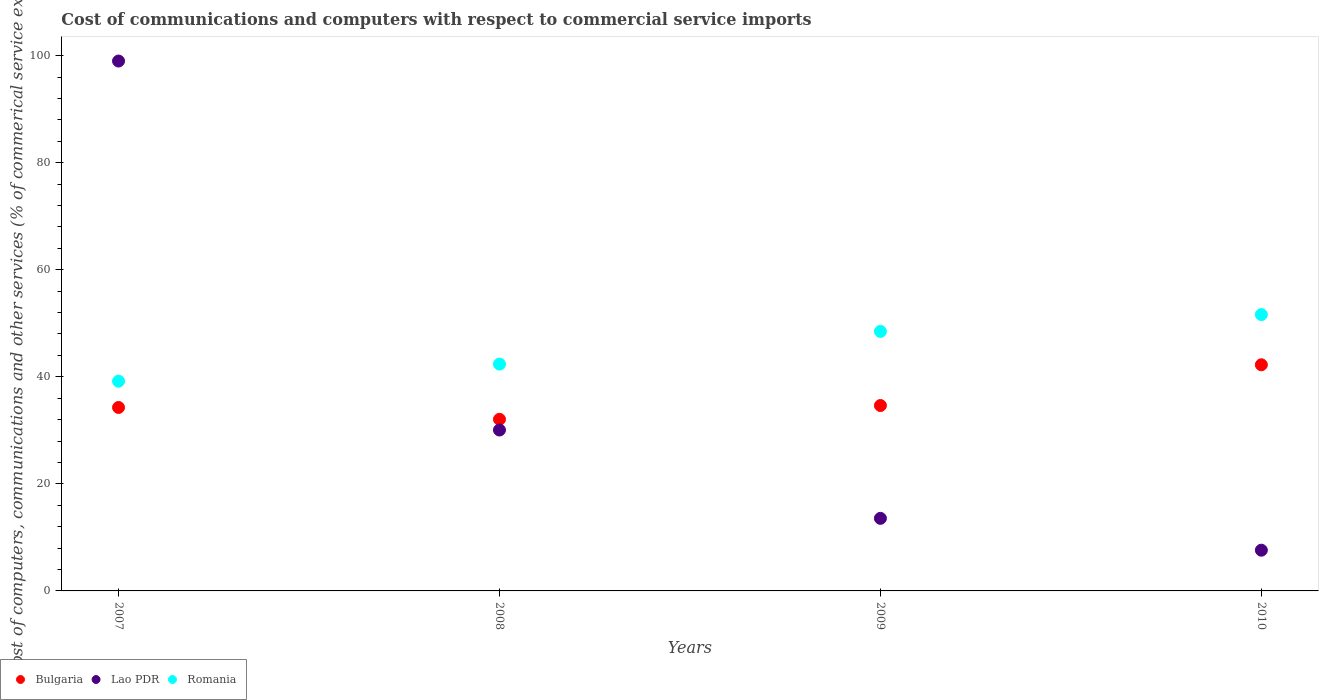How many different coloured dotlines are there?
Keep it short and to the point. 3. Is the number of dotlines equal to the number of legend labels?
Provide a short and direct response. Yes. What is the cost of communications and computers in Romania in 2009?
Ensure brevity in your answer.  48.48. Across all years, what is the maximum cost of communications and computers in Lao PDR?
Give a very brief answer. 98.99. Across all years, what is the minimum cost of communications and computers in Romania?
Provide a succinct answer. 39.18. In which year was the cost of communications and computers in Bulgaria maximum?
Your response must be concise. 2010. In which year was the cost of communications and computers in Romania minimum?
Offer a very short reply. 2007. What is the total cost of communications and computers in Bulgaria in the graph?
Offer a very short reply. 143.21. What is the difference between the cost of communications and computers in Lao PDR in 2008 and that in 2009?
Your response must be concise. 16.5. What is the difference between the cost of communications and computers in Romania in 2010 and the cost of communications and computers in Lao PDR in 2008?
Your answer should be very brief. 21.56. What is the average cost of communications and computers in Lao PDR per year?
Make the answer very short. 37.55. In the year 2010, what is the difference between the cost of communications and computers in Romania and cost of communications and computers in Lao PDR?
Provide a succinct answer. 44.01. In how many years, is the cost of communications and computers in Lao PDR greater than 56 %?
Offer a very short reply. 1. What is the ratio of the cost of communications and computers in Romania in 2007 to that in 2010?
Your response must be concise. 0.76. Is the difference between the cost of communications and computers in Romania in 2008 and 2010 greater than the difference between the cost of communications and computers in Lao PDR in 2008 and 2010?
Keep it short and to the point. No. What is the difference between the highest and the second highest cost of communications and computers in Lao PDR?
Your response must be concise. 68.93. What is the difference between the highest and the lowest cost of communications and computers in Lao PDR?
Offer a terse response. 91.38. In how many years, is the cost of communications and computers in Romania greater than the average cost of communications and computers in Romania taken over all years?
Your response must be concise. 2. Is the sum of the cost of communications and computers in Bulgaria in 2007 and 2008 greater than the maximum cost of communications and computers in Romania across all years?
Keep it short and to the point. Yes. How many dotlines are there?
Offer a very short reply. 3. What is the difference between two consecutive major ticks on the Y-axis?
Your response must be concise. 20. How many legend labels are there?
Provide a succinct answer. 3. How are the legend labels stacked?
Offer a very short reply. Horizontal. What is the title of the graph?
Ensure brevity in your answer.  Cost of communications and computers with respect to commercial service imports. Does "Liechtenstein" appear as one of the legend labels in the graph?
Your answer should be compact. No. What is the label or title of the Y-axis?
Provide a short and direct response. Cost of computers, communications and other services (% of commerical service exports). What is the Cost of computers, communications and other services (% of commerical service exports) in Bulgaria in 2007?
Your answer should be very brief. 34.27. What is the Cost of computers, communications and other services (% of commerical service exports) in Lao PDR in 2007?
Provide a short and direct response. 98.99. What is the Cost of computers, communications and other services (% of commerical service exports) in Romania in 2007?
Provide a short and direct response. 39.18. What is the Cost of computers, communications and other services (% of commerical service exports) of Bulgaria in 2008?
Keep it short and to the point. 32.06. What is the Cost of computers, communications and other services (% of commerical service exports) of Lao PDR in 2008?
Your response must be concise. 30.06. What is the Cost of computers, communications and other services (% of commerical service exports) of Romania in 2008?
Make the answer very short. 42.37. What is the Cost of computers, communications and other services (% of commerical service exports) of Bulgaria in 2009?
Offer a terse response. 34.63. What is the Cost of computers, communications and other services (% of commerical service exports) of Lao PDR in 2009?
Provide a short and direct response. 13.56. What is the Cost of computers, communications and other services (% of commerical service exports) of Romania in 2009?
Keep it short and to the point. 48.48. What is the Cost of computers, communications and other services (% of commerical service exports) of Bulgaria in 2010?
Offer a terse response. 42.25. What is the Cost of computers, communications and other services (% of commerical service exports) of Lao PDR in 2010?
Make the answer very short. 7.61. What is the Cost of computers, communications and other services (% of commerical service exports) of Romania in 2010?
Give a very brief answer. 51.62. Across all years, what is the maximum Cost of computers, communications and other services (% of commerical service exports) of Bulgaria?
Keep it short and to the point. 42.25. Across all years, what is the maximum Cost of computers, communications and other services (% of commerical service exports) of Lao PDR?
Your answer should be compact. 98.99. Across all years, what is the maximum Cost of computers, communications and other services (% of commerical service exports) in Romania?
Offer a terse response. 51.62. Across all years, what is the minimum Cost of computers, communications and other services (% of commerical service exports) of Bulgaria?
Give a very brief answer. 32.06. Across all years, what is the minimum Cost of computers, communications and other services (% of commerical service exports) of Lao PDR?
Your answer should be very brief. 7.61. Across all years, what is the minimum Cost of computers, communications and other services (% of commerical service exports) in Romania?
Offer a terse response. 39.18. What is the total Cost of computers, communications and other services (% of commerical service exports) of Bulgaria in the graph?
Your response must be concise. 143.21. What is the total Cost of computers, communications and other services (% of commerical service exports) of Lao PDR in the graph?
Your response must be concise. 150.21. What is the total Cost of computers, communications and other services (% of commerical service exports) in Romania in the graph?
Give a very brief answer. 181.66. What is the difference between the Cost of computers, communications and other services (% of commerical service exports) of Bulgaria in 2007 and that in 2008?
Make the answer very short. 2.21. What is the difference between the Cost of computers, communications and other services (% of commerical service exports) in Lao PDR in 2007 and that in 2008?
Keep it short and to the point. 68.93. What is the difference between the Cost of computers, communications and other services (% of commerical service exports) of Romania in 2007 and that in 2008?
Ensure brevity in your answer.  -3.19. What is the difference between the Cost of computers, communications and other services (% of commerical service exports) of Bulgaria in 2007 and that in 2009?
Make the answer very short. -0.36. What is the difference between the Cost of computers, communications and other services (% of commerical service exports) in Lao PDR in 2007 and that in 2009?
Provide a succinct answer. 85.43. What is the difference between the Cost of computers, communications and other services (% of commerical service exports) of Romania in 2007 and that in 2009?
Make the answer very short. -9.3. What is the difference between the Cost of computers, communications and other services (% of commerical service exports) in Bulgaria in 2007 and that in 2010?
Provide a succinct answer. -7.98. What is the difference between the Cost of computers, communications and other services (% of commerical service exports) of Lao PDR in 2007 and that in 2010?
Provide a short and direct response. 91.38. What is the difference between the Cost of computers, communications and other services (% of commerical service exports) in Romania in 2007 and that in 2010?
Offer a very short reply. -12.44. What is the difference between the Cost of computers, communications and other services (% of commerical service exports) in Bulgaria in 2008 and that in 2009?
Your answer should be compact. -2.58. What is the difference between the Cost of computers, communications and other services (% of commerical service exports) of Lao PDR in 2008 and that in 2009?
Offer a terse response. 16.5. What is the difference between the Cost of computers, communications and other services (% of commerical service exports) in Romania in 2008 and that in 2009?
Give a very brief answer. -6.11. What is the difference between the Cost of computers, communications and other services (% of commerical service exports) of Bulgaria in 2008 and that in 2010?
Give a very brief answer. -10.19. What is the difference between the Cost of computers, communications and other services (% of commerical service exports) of Lao PDR in 2008 and that in 2010?
Your response must be concise. 22.45. What is the difference between the Cost of computers, communications and other services (% of commerical service exports) of Romania in 2008 and that in 2010?
Provide a short and direct response. -9.25. What is the difference between the Cost of computers, communications and other services (% of commerical service exports) in Bulgaria in 2009 and that in 2010?
Give a very brief answer. -7.61. What is the difference between the Cost of computers, communications and other services (% of commerical service exports) in Lao PDR in 2009 and that in 2010?
Your response must be concise. 5.95. What is the difference between the Cost of computers, communications and other services (% of commerical service exports) of Romania in 2009 and that in 2010?
Keep it short and to the point. -3.14. What is the difference between the Cost of computers, communications and other services (% of commerical service exports) of Bulgaria in 2007 and the Cost of computers, communications and other services (% of commerical service exports) of Lao PDR in 2008?
Your answer should be compact. 4.21. What is the difference between the Cost of computers, communications and other services (% of commerical service exports) in Bulgaria in 2007 and the Cost of computers, communications and other services (% of commerical service exports) in Romania in 2008?
Offer a terse response. -8.1. What is the difference between the Cost of computers, communications and other services (% of commerical service exports) in Lao PDR in 2007 and the Cost of computers, communications and other services (% of commerical service exports) in Romania in 2008?
Your answer should be compact. 56.62. What is the difference between the Cost of computers, communications and other services (% of commerical service exports) in Bulgaria in 2007 and the Cost of computers, communications and other services (% of commerical service exports) in Lao PDR in 2009?
Offer a terse response. 20.71. What is the difference between the Cost of computers, communications and other services (% of commerical service exports) of Bulgaria in 2007 and the Cost of computers, communications and other services (% of commerical service exports) of Romania in 2009?
Provide a short and direct response. -14.21. What is the difference between the Cost of computers, communications and other services (% of commerical service exports) in Lao PDR in 2007 and the Cost of computers, communications and other services (% of commerical service exports) in Romania in 2009?
Give a very brief answer. 50.5. What is the difference between the Cost of computers, communications and other services (% of commerical service exports) of Bulgaria in 2007 and the Cost of computers, communications and other services (% of commerical service exports) of Lao PDR in 2010?
Offer a very short reply. 26.66. What is the difference between the Cost of computers, communications and other services (% of commerical service exports) in Bulgaria in 2007 and the Cost of computers, communications and other services (% of commerical service exports) in Romania in 2010?
Offer a very short reply. -17.35. What is the difference between the Cost of computers, communications and other services (% of commerical service exports) of Lao PDR in 2007 and the Cost of computers, communications and other services (% of commerical service exports) of Romania in 2010?
Provide a succinct answer. 47.36. What is the difference between the Cost of computers, communications and other services (% of commerical service exports) of Bulgaria in 2008 and the Cost of computers, communications and other services (% of commerical service exports) of Lao PDR in 2009?
Ensure brevity in your answer.  18.5. What is the difference between the Cost of computers, communications and other services (% of commerical service exports) in Bulgaria in 2008 and the Cost of computers, communications and other services (% of commerical service exports) in Romania in 2009?
Give a very brief answer. -16.43. What is the difference between the Cost of computers, communications and other services (% of commerical service exports) of Lao PDR in 2008 and the Cost of computers, communications and other services (% of commerical service exports) of Romania in 2009?
Your answer should be compact. -18.43. What is the difference between the Cost of computers, communications and other services (% of commerical service exports) in Bulgaria in 2008 and the Cost of computers, communications and other services (% of commerical service exports) in Lao PDR in 2010?
Provide a short and direct response. 24.45. What is the difference between the Cost of computers, communications and other services (% of commerical service exports) of Bulgaria in 2008 and the Cost of computers, communications and other services (% of commerical service exports) of Romania in 2010?
Your response must be concise. -19.57. What is the difference between the Cost of computers, communications and other services (% of commerical service exports) in Lao PDR in 2008 and the Cost of computers, communications and other services (% of commerical service exports) in Romania in 2010?
Provide a succinct answer. -21.56. What is the difference between the Cost of computers, communications and other services (% of commerical service exports) of Bulgaria in 2009 and the Cost of computers, communications and other services (% of commerical service exports) of Lao PDR in 2010?
Keep it short and to the point. 27.03. What is the difference between the Cost of computers, communications and other services (% of commerical service exports) in Bulgaria in 2009 and the Cost of computers, communications and other services (% of commerical service exports) in Romania in 2010?
Keep it short and to the point. -16.99. What is the difference between the Cost of computers, communications and other services (% of commerical service exports) in Lao PDR in 2009 and the Cost of computers, communications and other services (% of commerical service exports) in Romania in 2010?
Provide a succinct answer. -38.06. What is the average Cost of computers, communications and other services (% of commerical service exports) of Bulgaria per year?
Provide a succinct answer. 35.8. What is the average Cost of computers, communications and other services (% of commerical service exports) of Lao PDR per year?
Offer a very short reply. 37.55. What is the average Cost of computers, communications and other services (% of commerical service exports) of Romania per year?
Your answer should be very brief. 45.41. In the year 2007, what is the difference between the Cost of computers, communications and other services (% of commerical service exports) of Bulgaria and Cost of computers, communications and other services (% of commerical service exports) of Lao PDR?
Make the answer very short. -64.72. In the year 2007, what is the difference between the Cost of computers, communications and other services (% of commerical service exports) in Bulgaria and Cost of computers, communications and other services (% of commerical service exports) in Romania?
Offer a terse response. -4.91. In the year 2007, what is the difference between the Cost of computers, communications and other services (% of commerical service exports) of Lao PDR and Cost of computers, communications and other services (% of commerical service exports) of Romania?
Give a very brief answer. 59.81. In the year 2008, what is the difference between the Cost of computers, communications and other services (% of commerical service exports) of Bulgaria and Cost of computers, communications and other services (% of commerical service exports) of Lao PDR?
Make the answer very short. 2. In the year 2008, what is the difference between the Cost of computers, communications and other services (% of commerical service exports) in Bulgaria and Cost of computers, communications and other services (% of commerical service exports) in Romania?
Give a very brief answer. -10.31. In the year 2008, what is the difference between the Cost of computers, communications and other services (% of commerical service exports) of Lao PDR and Cost of computers, communications and other services (% of commerical service exports) of Romania?
Offer a terse response. -12.31. In the year 2009, what is the difference between the Cost of computers, communications and other services (% of commerical service exports) in Bulgaria and Cost of computers, communications and other services (% of commerical service exports) in Lao PDR?
Provide a short and direct response. 21.08. In the year 2009, what is the difference between the Cost of computers, communications and other services (% of commerical service exports) of Bulgaria and Cost of computers, communications and other services (% of commerical service exports) of Romania?
Your answer should be compact. -13.85. In the year 2009, what is the difference between the Cost of computers, communications and other services (% of commerical service exports) of Lao PDR and Cost of computers, communications and other services (% of commerical service exports) of Romania?
Your response must be concise. -34.93. In the year 2010, what is the difference between the Cost of computers, communications and other services (% of commerical service exports) of Bulgaria and Cost of computers, communications and other services (% of commerical service exports) of Lao PDR?
Make the answer very short. 34.64. In the year 2010, what is the difference between the Cost of computers, communications and other services (% of commerical service exports) of Bulgaria and Cost of computers, communications and other services (% of commerical service exports) of Romania?
Your answer should be very brief. -9.38. In the year 2010, what is the difference between the Cost of computers, communications and other services (% of commerical service exports) in Lao PDR and Cost of computers, communications and other services (% of commerical service exports) in Romania?
Ensure brevity in your answer.  -44.01. What is the ratio of the Cost of computers, communications and other services (% of commerical service exports) of Bulgaria in 2007 to that in 2008?
Give a very brief answer. 1.07. What is the ratio of the Cost of computers, communications and other services (% of commerical service exports) in Lao PDR in 2007 to that in 2008?
Make the answer very short. 3.29. What is the ratio of the Cost of computers, communications and other services (% of commerical service exports) of Romania in 2007 to that in 2008?
Ensure brevity in your answer.  0.92. What is the ratio of the Cost of computers, communications and other services (% of commerical service exports) of Lao PDR in 2007 to that in 2009?
Provide a succinct answer. 7.3. What is the ratio of the Cost of computers, communications and other services (% of commerical service exports) in Romania in 2007 to that in 2009?
Your answer should be compact. 0.81. What is the ratio of the Cost of computers, communications and other services (% of commerical service exports) of Bulgaria in 2007 to that in 2010?
Provide a short and direct response. 0.81. What is the ratio of the Cost of computers, communications and other services (% of commerical service exports) in Lao PDR in 2007 to that in 2010?
Your answer should be compact. 13.01. What is the ratio of the Cost of computers, communications and other services (% of commerical service exports) in Romania in 2007 to that in 2010?
Provide a short and direct response. 0.76. What is the ratio of the Cost of computers, communications and other services (% of commerical service exports) of Bulgaria in 2008 to that in 2009?
Offer a very short reply. 0.93. What is the ratio of the Cost of computers, communications and other services (% of commerical service exports) of Lao PDR in 2008 to that in 2009?
Your answer should be very brief. 2.22. What is the ratio of the Cost of computers, communications and other services (% of commerical service exports) of Romania in 2008 to that in 2009?
Provide a short and direct response. 0.87. What is the ratio of the Cost of computers, communications and other services (% of commerical service exports) of Bulgaria in 2008 to that in 2010?
Provide a succinct answer. 0.76. What is the ratio of the Cost of computers, communications and other services (% of commerical service exports) in Lao PDR in 2008 to that in 2010?
Your response must be concise. 3.95. What is the ratio of the Cost of computers, communications and other services (% of commerical service exports) of Romania in 2008 to that in 2010?
Your answer should be compact. 0.82. What is the ratio of the Cost of computers, communications and other services (% of commerical service exports) of Bulgaria in 2009 to that in 2010?
Make the answer very short. 0.82. What is the ratio of the Cost of computers, communications and other services (% of commerical service exports) in Lao PDR in 2009 to that in 2010?
Offer a terse response. 1.78. What is the ratio of the Cost of computers, communications and other services (% of commerical service exports) in Romania in 2009 to that in 2010?
Offer a very short reply. 0.94. What is the difference between the highest and the second highest Cost of computers, communications and other services (% of commerical service exports) of Bulgaria?
Provide a succinct answer. 7.61. What is the difference between the highest and the second highest Cost of computers, communications and other services (% of commerical service exports) of Lao PDR?
Your answer should be compact. 68.93. What is the difference between the highest and the second highest Cost of computers, communications and other services (% of commerical service exports) of Romania?
Make the answer very short. 3.14. What is the difference between the highest and the lowest Cost of computers, communications and other services (% of commerical service exports) of Bulgaria?
Your response must be concise. 10.19. What is the difference between the highest and the lowest Cost of computers, communications and other services (% of commerical service exports) of Lao PDR?
Your response must be concise. 91.38. What is the difference between the highest and the lowest Cost of computers, communications and other services (% of commerical service exports) of Romania?
Ensure brevity in your answer.  12.44. 